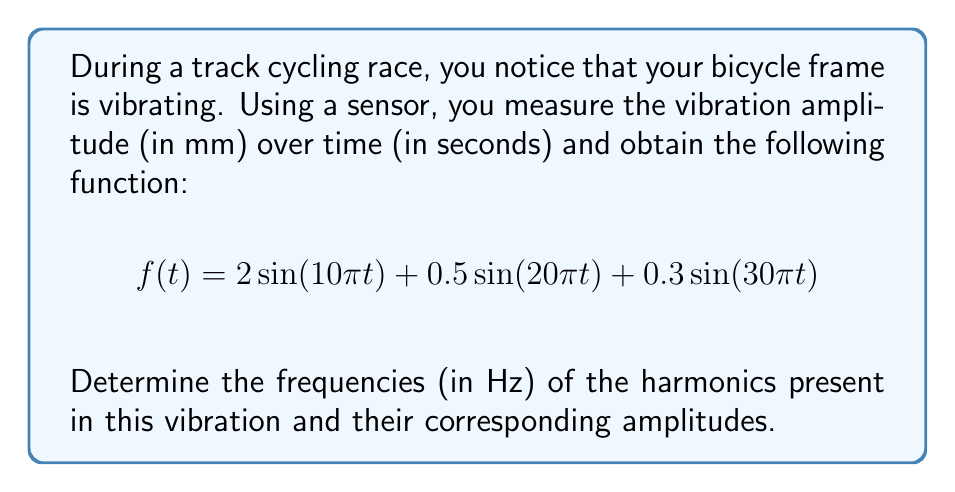Teach me how to tackle this problem. To solve this problem, we need to analyze the given function and identify the harmonics. The general form of a sinusoidal function is:

$$A\sin(2\pi ft)$$

where $A$ is the amplitude, $f$ is the frequency in Hz, and $t$ is time in seconds.

Let's break down the given function:

1. First term: $2\sin(10\pi t)$
   - Amplitude: $A_1 = 2$
   - Angular frequency: $\omega_1 = 10\pi$
   - Frequency: $f_1 = \frac{\omega_1}{2\pi} = \frac{10\pi}{2\pi} = 5$ Hz

2. Second term: $0.5\sin(20\pi t)$
   - Amplitude: $A_2 = 0.5$
   - Angular frequency: $\omega_2 = 20\pi$
   - Frequency: $f_2 = \frac{\omega_2}{2\pi} = \frac{20\pi}{2\pi} = 10$ Hz

3. Third term: $0.3\sin(30\pi t)$
   - Amplitude: $A_3 = 0.3$
   - Angular frequency: $\omega_3 = 30\pi$
   - Frequency: $f_3 = \frac{\omega_3}{2\pi} = \frac{30\pi}{2\pi} = 15$ Hz

The harmonics are the different frequency components present in the vibration. In this case, we have three harmonics:

1. First harmonic (fundamental frequency): 5 Hz with amplitude 2 mm
2. Second harmonic: 10 Hz with amplitude 0.5 mm
3. Third harmonic: 15 Hz with amplitude 0.3 mm

Note that the frequencies are multiples of the fundamental frequency (5 Hz), which is typical for harmonics in mechanical systems.
Answer: The harmonics present in the vibration are:
1. 5 Hz with amplitude 2 mm
2. 10 Hz with amplitude 0.5 mm
3. 15 Hz with amplitude 0.3 mm 